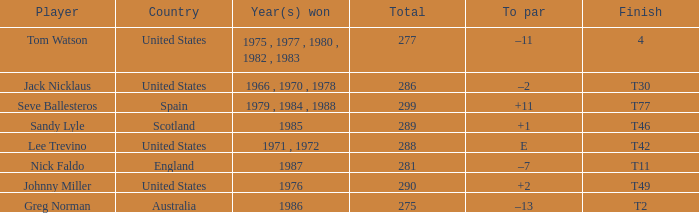What's the finish for the total 288? T42. 